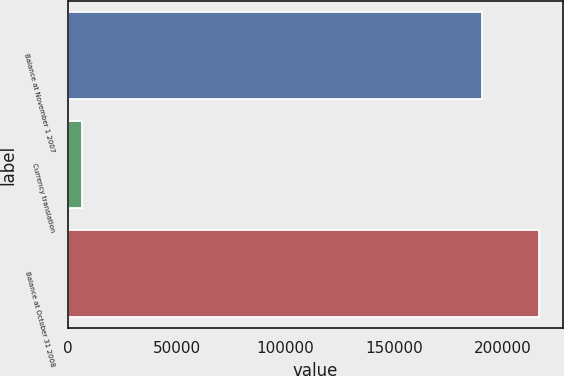<chart> <loc_0><loc_0><loc_500><loc_500><bar_chart><fcel>Balance at November 1 2007<fcel>Currency translation<fcel>Balance at October 31 2008<nl><fcel>190125<fcel>6489<fcel>216657<nl></chart> 